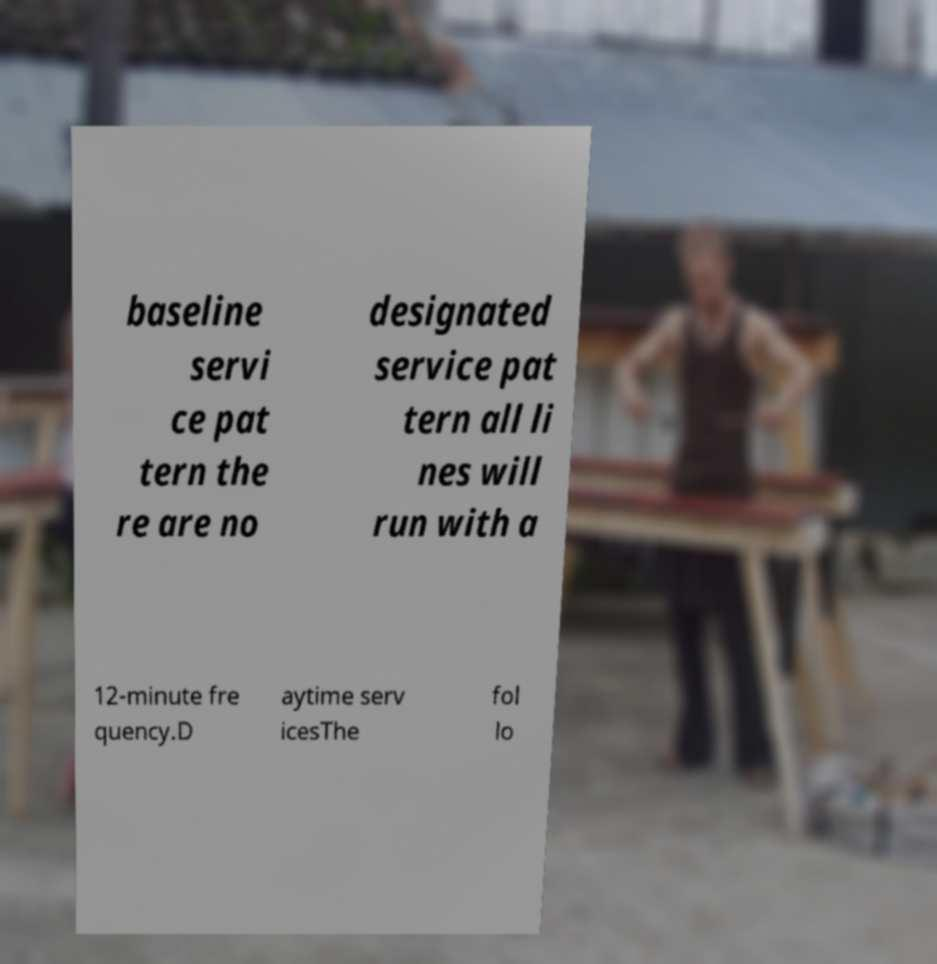For documentation purposes, I need the text within this image transcribed. Could you provide that? baseline servi ce pat tern the re are no designated service pat tern all li nes will run with a 12-minute fre quency.D aytime serv icesThe fol lo 